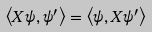<formula> <loc_0><loc_0><loc_500><loc_500>\left < X \psi , \psi ^ { \prime } \right > = \left < \psi , X \psi ^ { \prime } \right ></formula> 